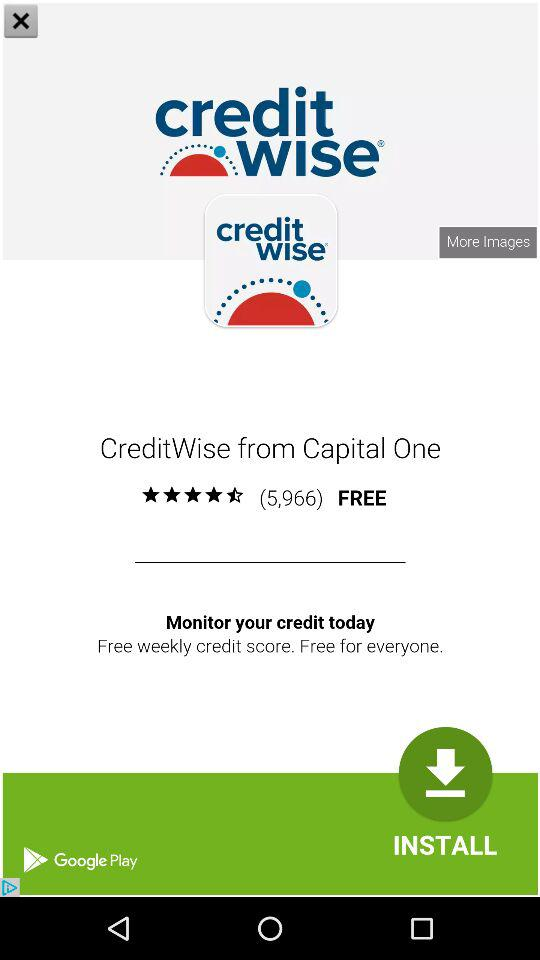Is the app free or paid? The app is free. 